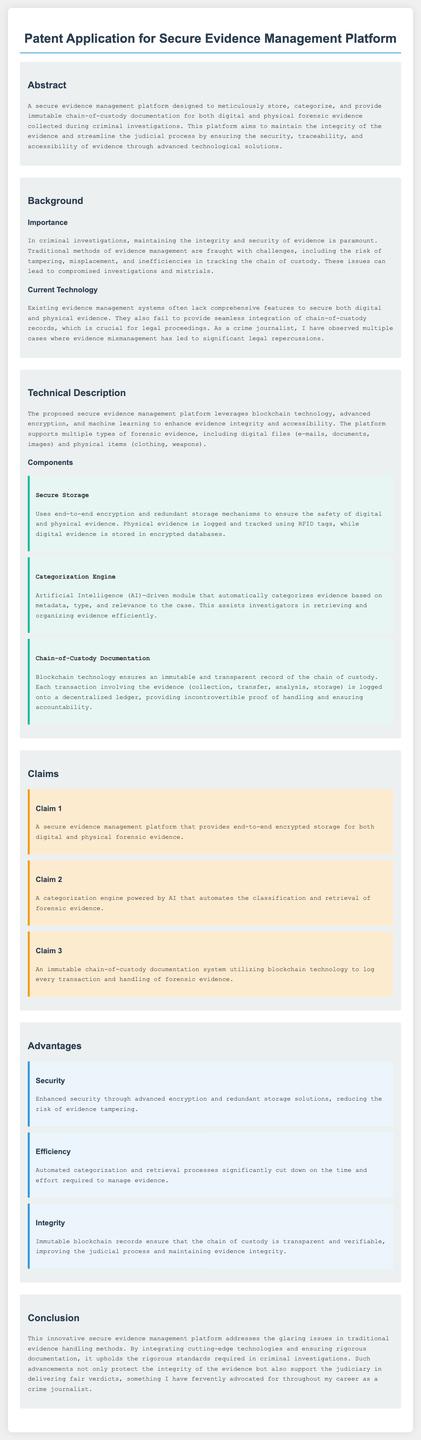What is the title of the patent application? The title of the patent application is explicitly stated at the beginning of the document.
Answer: Patent Application for Secure Evidence Management Platform What technology does the platform utilize for chain-of-custody documentation? The document mentions that the platform uses blockchain technology for maintaining chain-of-custody records.
Answer: Blockchain technology What advantage is highlighted related to security? The advantages section outlines the enhancements in security due to advanced encryption and redundant storage.
Answer: Enhanced security How many claims are there in the document? The claims section lists a total of three unique claims regarding the platform.
Answer: Three What type of evidence does the secure evidence management platform support? The document specifies that the platform supports both digital files and physical items as types of forensic evidence.
Answer: Both digital and physical evidence What is the purpose of the categorization engine? The purpose of the categorization engine is described as automating the classification and retrieval of forensic evidence.
Answer: Automates classification and retrieval What is emphasized as paramount in criminal investigations? The background section states that maintaining the integrity and security of evidence is paramount in criminal investigations.
Answer: Integrity and security of evidence What issue does the document highlight in current technology? The document mentions that existing systems often lack comprehensive features for securing both digital and physical evidence.
Answer: Lack of comprehensive features 